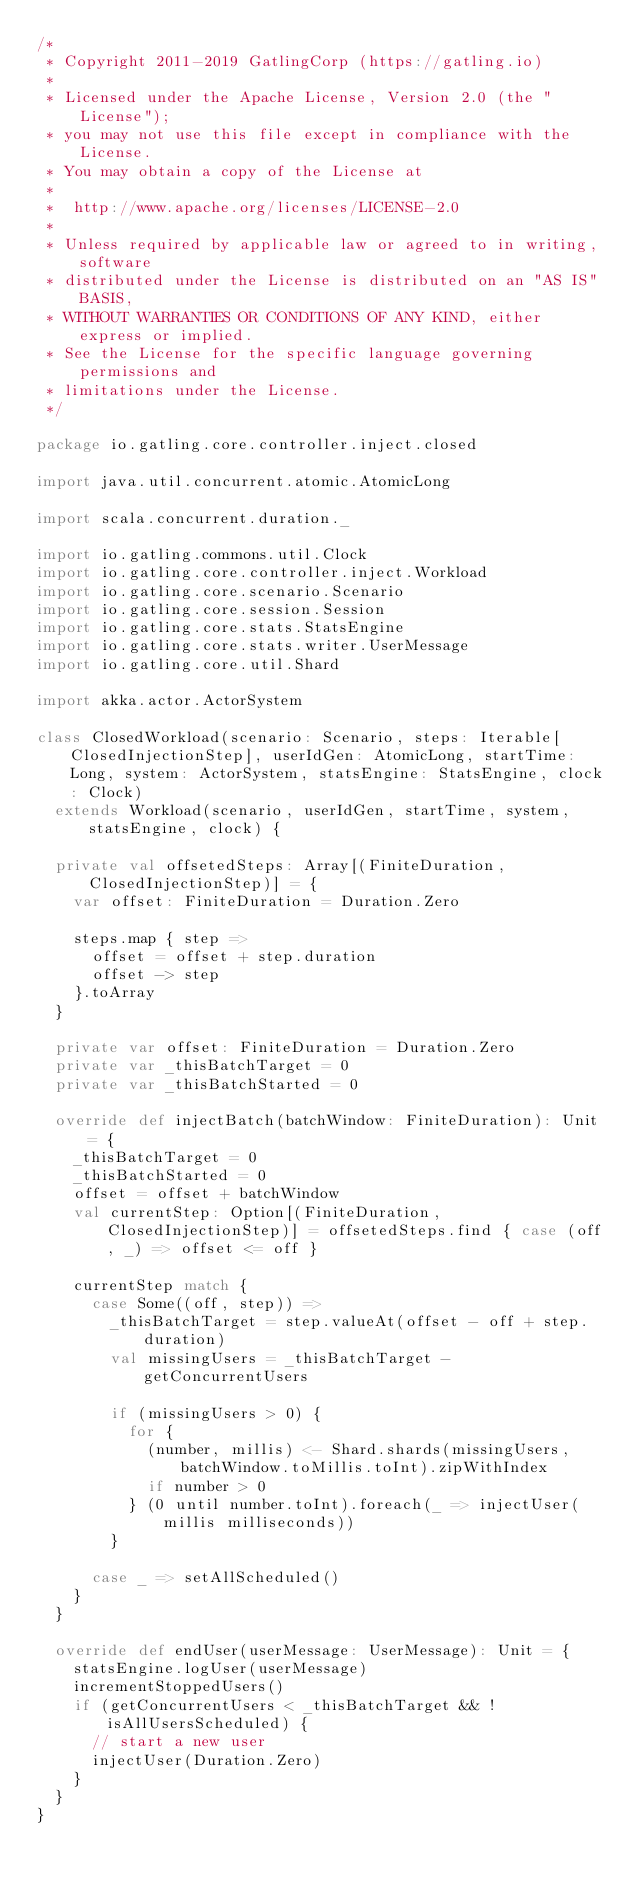<code> <loc_0><loc_0><loc_500><loc_500><_Scala_>/*
 * Copyright 2011-2019 GatlingCorp (https://gatling.io)
 *
 * Licensed under the Apache License, Version 2.0 (the "License");
 * you may not use this file except in compliance with the License.
 * You may obtain a copy of the License at
 *
 *  http://www.apache.org/licenses/LICENSE-2.0
 *
 * Unless required by applicable law or agreed to in writing, software
 * distributed under the License is distributed on an "AS IS" BASIS,
 * WITHOUT WARRANTIES OR CONDITIONS OF ANY KIND, either express or implied.
 * See the License for the specific language governing permissions and
 * limitations under the License.
 */

package io.gatling.core.controller.inject.closed

import java.util.concurrent.atomic.AtomicLong

import scala.concurrent.duration._

import io.gatling.commons.util.Clock
import io.gatling.core.controller.inject.Workload
import io.gatling.core.scenario.Scenario
import io.gatling.core.session.Session
import io.gatling.core.stats.StatsEngine
import io.gatling.core.stats.writer.UserMessage
import io.gatling.core.util.Shard

import akka.actor.ActorSystem

class ClosedWorkload(scenario: Scenario, steps: Iterable[ClosedInjectionStep], userIdGen: AtomicLong, startTime: Long, system: ActorSystem, statsEngine: StatsEngine, clock: Clock)
  extends Workload(scenario, userIdGen, startTime, system, statsEngine, clock) {

  private val offsetedSteps: Array[(FiniteDuration, ClosedInjectionStep)] = {
    var offset: FiniteDuration = Duration.Zero

    steps.map { step =>
      offset = offset + step.duration
      offset -> step
    }.toArray
  }

  private var offset: FiniteDuration = Duration.Zero
  private var _thisBatchTarget = 0
  private var _thisBatchStarted = 0

  override def injectBatch(batchWindow: FiniteDuration): Unit = {
    _thisBatchTarget = 0
    _thisBatchStarted = 0
    offset = offset + batchWindow
    val currentStep: Option[(FiniteDuration, ClosedInjectionStep)] = offsetedSteps.find { case (off, _) => offset <= off }

    currentStep match {
      case Some((off, step)) =>
        _thisBatchTarget = step.valueAt(offset - off + step.duration)
        val missingUsers = _thisBatchTarget - getConcurrentUsers

        if (missingUsers > 0) {
          for {
            (number, millis) <- Shard.shards(missingUsers, batchWindow.toMillis.toInt).zipWithIndex
            if number > 0
          } (0 until number.toInt).foreach(_ => injectUser(millis milliseconds))
        }

      case _ => setAllScheduled()
    }
  }

  override def endUser(userMessage: UserMessage): Unit = {
    statsEngine.logUser(userMessage)
    incrementStoppedUsers()
    if (getConcurrentUsers < _thisBatchTarget && !isAllUsersScheduled) {
      // start a new user
      injectUser(Duration.Zero)
    }
  }
}
</code> 